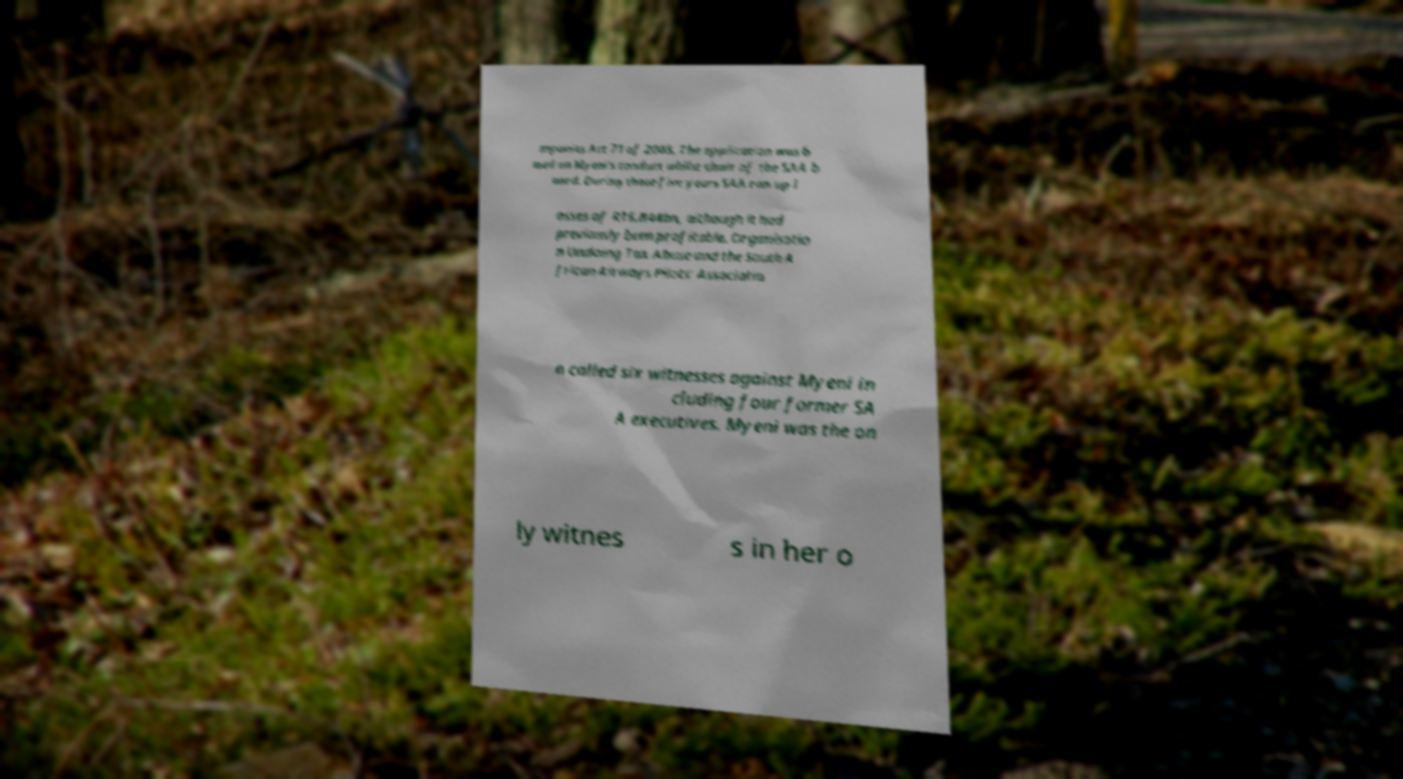For documentation purposes, I need the text within this image transcribed. Could you provide that? mpanies Act 71 of 2008. The application was b ased on Myeni's conduct whilst chair of the SAA b oard. During those five years SAA ran up l osses of R16.844bn‚ although it had previously been profitable. Organisatio n Undoing Tax Abuse and the South A frican Airways Pilots' Associatio n called six witnesses against Myeni in cluding four former SA A executives. Myeni was the on ly witnes s in her o 